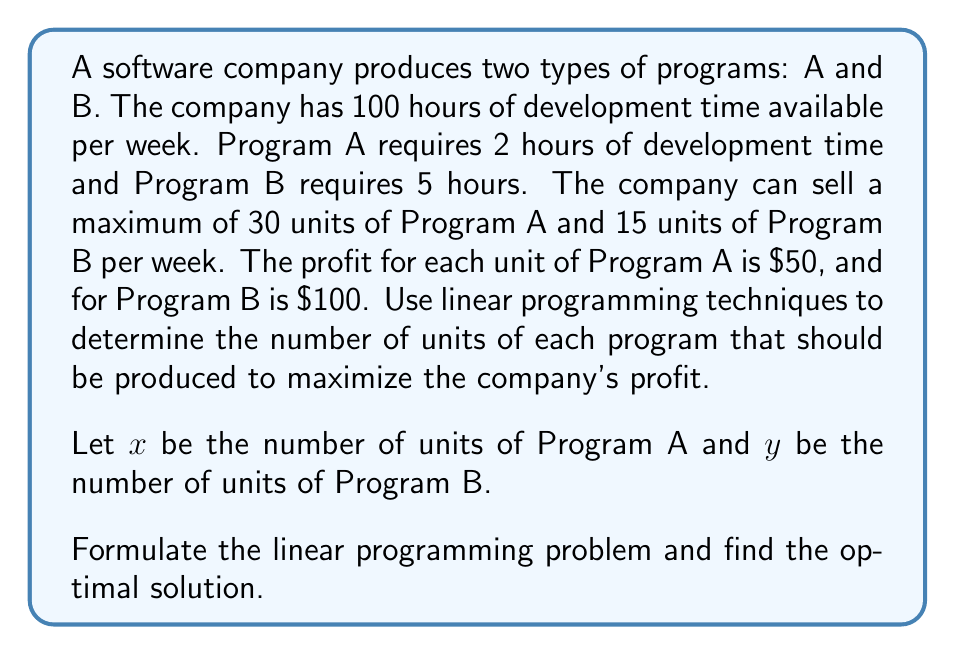Solve this math problem. To solve this problem using linear programming techniques, we'll follow these steps:

1. Define the objective function
2. Identify the constraints
3. Graph the feasible region
4. Find the optimal solution

Step 1: Define the objective function
The objective is to maximize profit. Let P be the total profit.
$$P = 50x + 100y$$

Step 2: Identify the constraints
a) Development time constraint: $2x + 5y \leq 100$
b) Maximum units of Program A: $x \leq 30$
c) Maximum units of Program B: $y \leq 15$
d) Non-negativity constraints: $x \geq 0, y \geq 0$

Step 3: Graph the feasible region
We'll graph the constraints to visualize the feasible region:

[asy]
import graph;
size(200);
xaxis("x", 0, 35, Arrow);
yaxis("y", 0, 25, Arrow);

draw((0,20)--(50,0), blue);
draw((30,0)--(30,25), red);
draw((0,15)--(35,15), green);

fill((0,0)--(30,0)--(30,15)--(20,15)--(0,20)--cycle, lightgray);

label("$2x+5y=100$", (45,2), blue);
label("$x=30$", (31,12), red);
label("$y=15$", (15,16), green);

dot((0,20));
dot((30,0));
dot((30,15));
dot((20,15));
[/asy]

The shaded region represents the feasible region.

Step 4: Find the optimal solution
The optimal solution will be at one of the corner points of the feasible region. We'll evaluate the objective function at each corner point:

a) (0, 0): $P = 50(0) + 100(0) = 0$
b) (30, 0): $P = 50(30) + 100(0) = 1500$
c) (30, 8): $P = 50(30) + 100(8) = 2300$
d) (20, 15): $P = 50(20) + 100(15) = 2500$
e) (0, 20): $P = 50(0) + 100(20) = 2000$

The maximum profit occurs at point (20, 15).
Answer: The optimal solution is to produce 20 units of Program A and 15 units of Program B, resulting in a maximum profit of $2500 per week. 